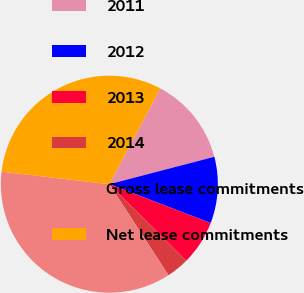Convert chart. <chart><loc_0><loc_0><loc_500><loc_500><pie_chart><fcel>2011<fcel>2012<fcel>2013<fcel>2014<fcel>Gross lease commitments<fcel>Net lease commitments<nl><fcel>13.16%<fcel>9.89%<fcel>6.63%<fcel>3.37%<fcel>36.01%<fcel>30.94%<nl></chart> 